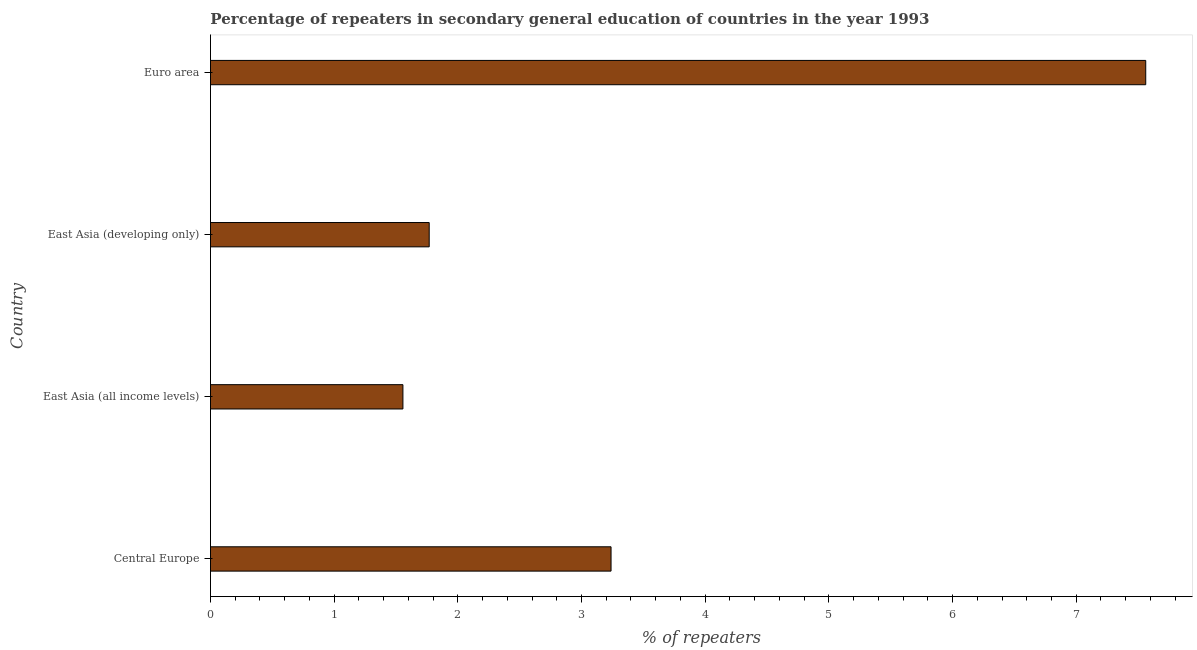Does the graph contain any zero values?
Ensure brevity in your answer.  No. Does the graph contain grids?
Provide a succinct answer. No. What is the title of the graph?
Your answer should be compact. Percentage of repeaters in secondary general education of countries in the year 1993. What is the label or title of the X-axis?
Offer a terse response. % of repeaters. What is the percentage of repeaters in Central Europe?
Provide a succinct answer. 3.24. Across all countries, what is the maximum percentage of repeaters?
Your answer should be very brief. 7.56. Across all countries, what is the minimum percentage of repeaters?
Give a very brief answer. 1.56. In which country was the percentage of repeaters maximum?
Offer a terse response. Euro area. In which country was the percentage of repeaters minimum?
Provide a short and direct response. East Asia (all income levels). What is the sum of the percentage of repeaters?
Offer a very short reply. 14.13. What is the difference between the percentage of repeaters in East Asia (all income levels) and Euro area?
Ensure brevity in your answer.  -6.01. What is the average percentage of repeaters per country?
Provide a succinct answer. 3.53. What is the median percentage of repeaters?
Offer a terse response. 2.5. In how many countries, is the percentage of repeaters greater than 7.4 %?
Your answer should be very brief. 1. What is the ratio of the percentage of repeaters in Central Europe to that in East Asia (developing only)?
Your answer should be compact. 1.83. Is the percentage of repeaters in East Asia (all income levels) less than that in Euro area?
Ensure brevity in your answer.  Yes. Is the difference between the percentage of repeaters in Central Europe and Euro area greater than the difference between any two countries?
Provide a succinct answer. No. What is the difference between the highest and the second highest percentage of repeaters?
Your answer should be compact. 4.32. Is the sum of the percentage of repeaters in East Asia (all income levels) and Euro area greater than the maximum percentage of repeaters across all countries?
Your answer should be compact. Yes. What is the difference between the highest and the lowest percentage of repeaters?
Offer a terse response. 6.01. In how many countries, is the percentage of repeaters greater than the average percentage of repeaters taken over all countries?
Provide a short and direct response. 1. How many bars are there?
Make the answer very short. 4. How many countries are there in the graph?
Offer a terse response. 4. What is the % of repeaters in Central Europe?
Provide a short and direct response. 3.24. What is the % of repeaters in East Asia (all income levels)?
Offer a very short reply. 1.56. What is the % of repeaters of East Asia (developing only)?
Make the answer very short. 1.77. What is the % of repeaters of Euro area?
Your answer should be very brief. 7.56. What is the difference between the % of repeaters in Central Europe and East Asia (all income levels)?
Provide a succinct answer. 1.68. What is the difference between the % of repeaters in Central Europe and East Asia (developing only)?
Make the answer very short. 1.47. What is the difference between the % of repeaters in Central Europe and Euro area?
Offer a very short reply. -4.32. What is the difference between the % of repeaters in East Asia (all income levels) and East Asia (developing only)?
Offer a terse response. -0.21. What is the difference between the % of repeaters in East Asia (all income levels) and Euro area?
Keep it short and to the point. -6.01. What is the difference between the % of repeaters in East Asia (developing only) and Euro area?
Offer a very short reply. -5.79. What is the ratio of the % of repeaters in Central Europe to that in East Asia (all income levels)?
Your answer should be compact. 2.08. What is the ratio of the % of repeaters in Central Europe to that in East Asia (developing only)?
Provide a succinct answer. 1.83. What is the ratio of the % of repeaters in Central Europe to that in Euro area?
Make the answer very short. 0.43. What is the ratio of the % of repeaters in East Asia (all income levels) to that in Euro area?
Give a very brief answer. 0.21. What is the ratio of the % of repeaters in East Asia (developing only) to that in Euro area?
Your answer should be compact. 0.23. 